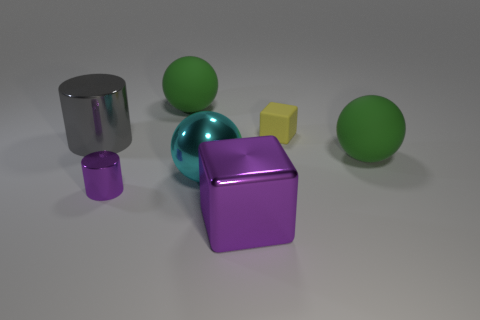Add 3 blue balls. How many objects exist? 10 Subtract all cubes. How many objects are left? 5 Add 2 big brown matte spheres. How many big brown matte spheres exist? 2 Subtract 0 red balls. How many objects are left? 7 Subtract all purple things. Subtract all large red metal spheres. How many objects are left? 5 Add 3 cylinders. How many cylinders are left? 5 